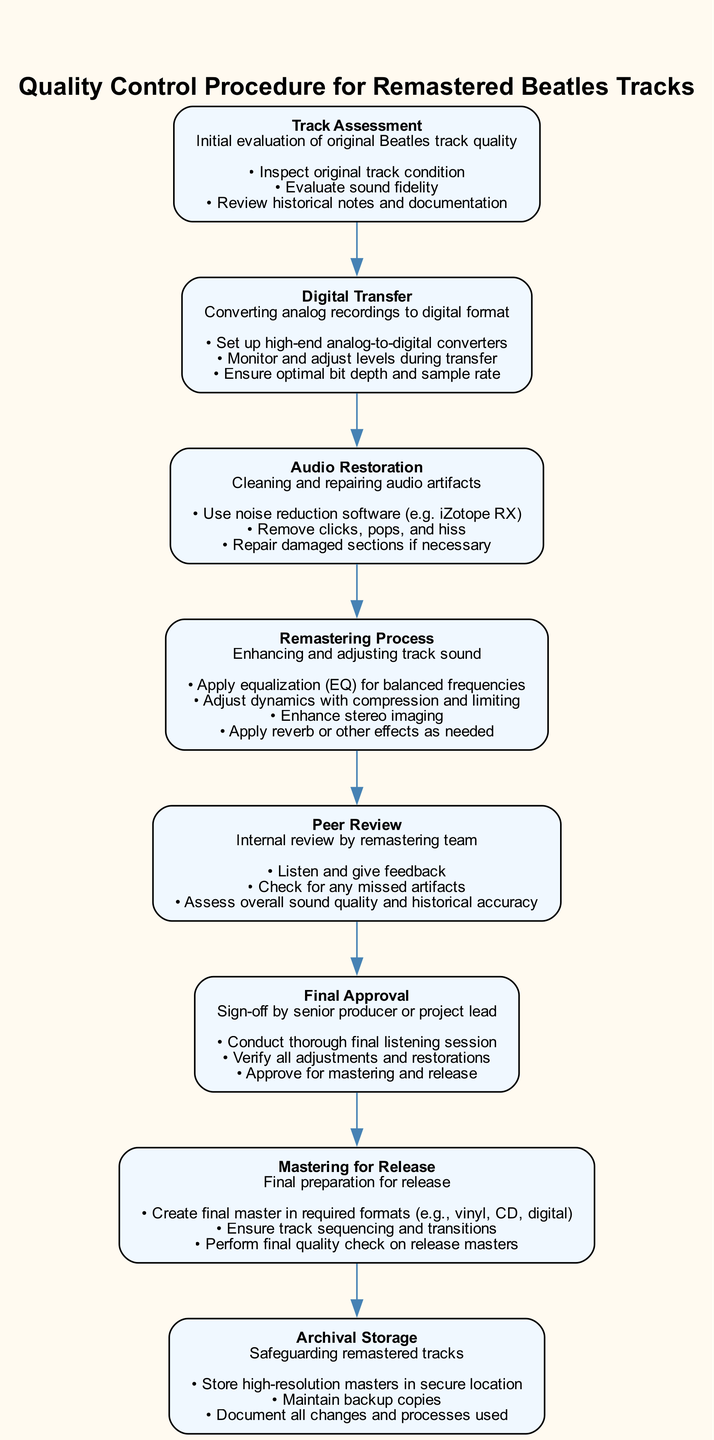What's the first step in the quality control procedure? The first step in the diagram is "Track Assessment," which is where the original Beatles track quality is initially evaluated.
Answer: Track Assessment How many tasks are there in the "Digital Transfer" step? In the "Digital Transfer" section, there are three tasks listed: setting up converters, monitoring levels, and ensuring optimal formats.
Answer: 3 What is the last step before the "Archival Storage"? The step just before “Archival Storage” is “Mastering for Release,” which involves final preparations for releasing the remastered tracks.
Answer: Mastering for Release Which element comes after "Audio Restoration"? Following “Audio Restoration,” the next element is “Remastering Process,” which focuses on enhancing and adjusting the track sound.
Answer: Remastering Process What is the purpose of the "Peer Review"? The purpose of the "Peer Review" is to conduct an internal review by the remastering team to listen and provide feedback on the track quality.
Answer: Internal review Can you list the elements in the correct order from start to finish? The elements in order are: Track Assessment, Digital Transfer, Audio Restoration, Remastering Process, Peer Review, Final Approval, Mastering for Release, Archival Storage. This represents the complete flow of the quality control process.
Answer: Track Assessment, Digital Transfer, Audio Restoration, Remastering Process, Peer Review, Final Approval, Mastering for Release, Archival Storage What type of software is mentioned for audio restoration? The diagram specifies using noise reduction software, namely “iZotope RX,” which indicates a specific tool for cleaning audio artifacts.
Answer: iZotope RX How many total elements are in the quality control procedure? The diagram shows there are eight distinct elements in the quality control procedure for remastered tracks, displaying different stages and tasks involved.
Answer: 8 